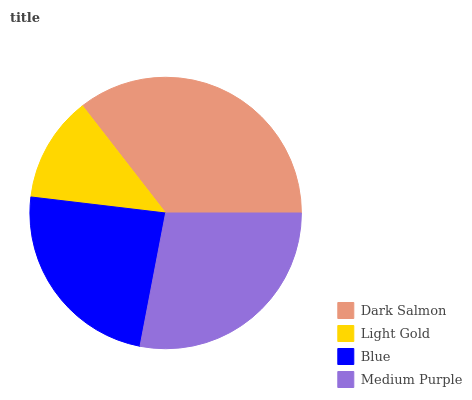Is Light Gold the minimum?
Answer yes or no. Yes. Is Dark Salmon the maximum?
Answer yes or no. Yes. Is Blue the minimum?
Answer yes or no. No. Is Blue the maximum?
Answer yes or no. No. Is Blue greater than Light Gold?
Answer yes or no. Yes. Is Light Gold less than Blue?
Answer yes or no. Yes. Is Light Gold greater than Blue?
Answer yes or no. No. Is Blue less than Light Gold?
Answer yes or no. No. Is Medium Purple the high median?
Answer yes or no. Yes. Is Blue the low median?
Answer yes or no. Yes. Is Light Gold the high median?
Answer yes or no. No. Is Medium Purple the low median?
Answer yes or no. No. 